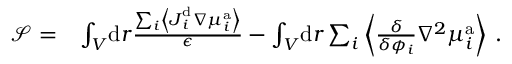<formula> <loc_0><loc_0><loc_500><loc_500>\begin{array} { r l } { \mathcal { S } = } & { \int _ { V } \, d r \frac { \sum _ { i } \left \langle J _ { i } ^ { d } \nabla { \mu } _ { i } ^ { a } \right \rangle } { \epsilon } - \int _ { V } \, d r \sum _ { i } \left \langle \frac { \delta } { \delta { \phi _ { i } } } \nabla ^ { 2 } \mu _ { i } ^ { a } \right \rangle \, . } \end{array}</formula> 